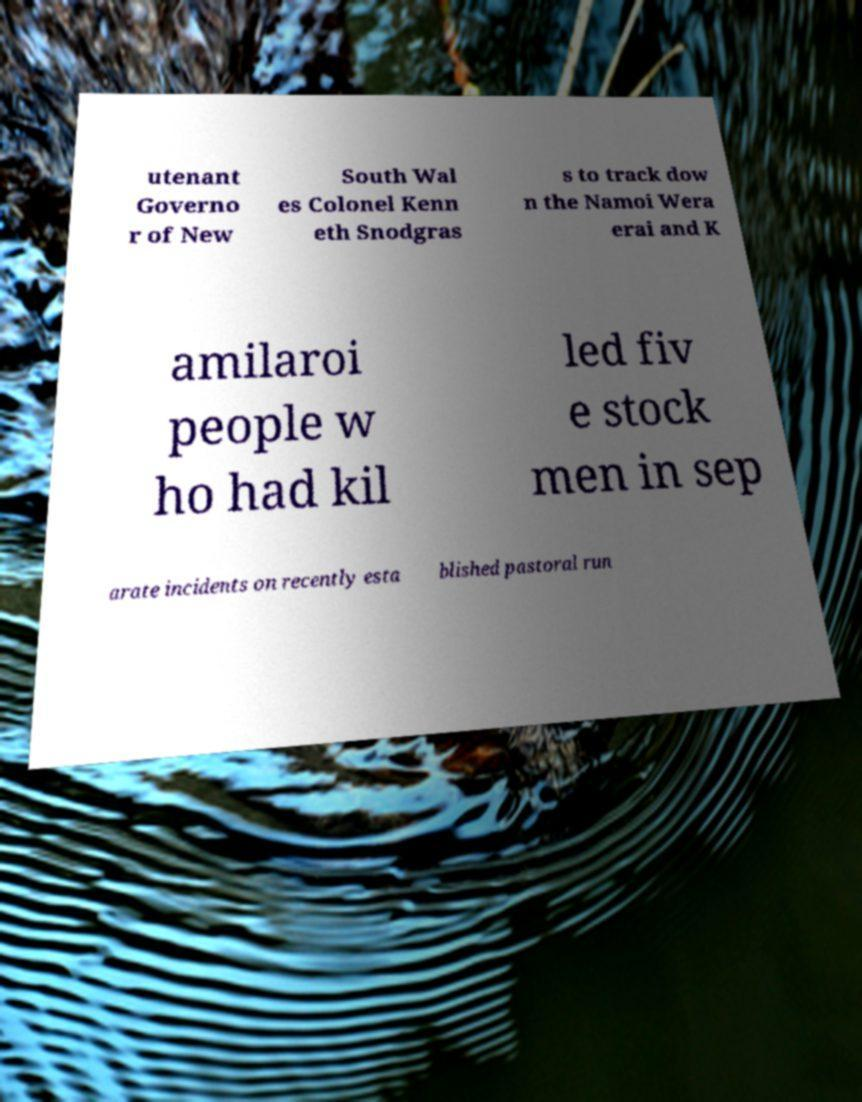Could you assist in decoding the text presented in this image and type it out clearly? utenant Governo r of New South Wal es Colonel Kenn eth Snodgras s to track dow n the Namoi Wera erai and K amilaroi people w ho had kil led fiv e stock men in sep arate incidents on recently esta blished pastoral run 